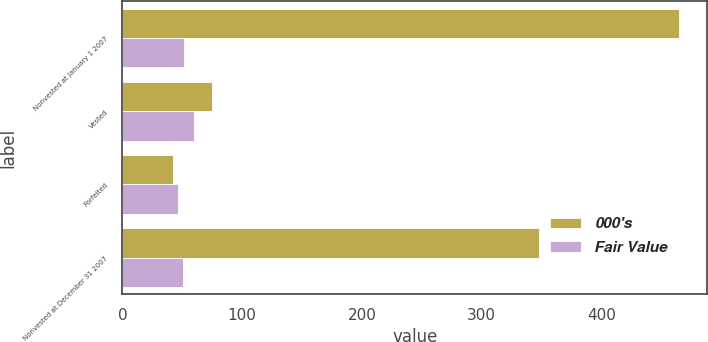<chart> <loc_0><loc_0><loc_500><loc_500><stacked_bar_chart><ecel><fcel>Nonvested at January 1 2007<fcel>Vested<fcel>Forfeited<fcel>Nonvested at December 31 2007<nl><fcel>000's<fcel>465<fcel>75<fcel>42<fcel>348<nl><fcel>Fair Value<fcel>51.14<fcel>59.55<fcel>46.32<fcel>50.3<nl></chart> 